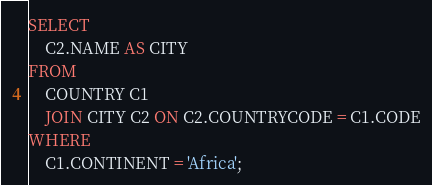<code> <loc_0><loc_0><loc_500><loc_500><_SQL_>SELECT
    C2.NAME AS CITY
FROM
    COUNTRY C1
    JOIN CITY C2 ON C2.COUNTRYCODE = C1.CODE
WHERE
    C1.CONTINENT = 'Africa';</code> 